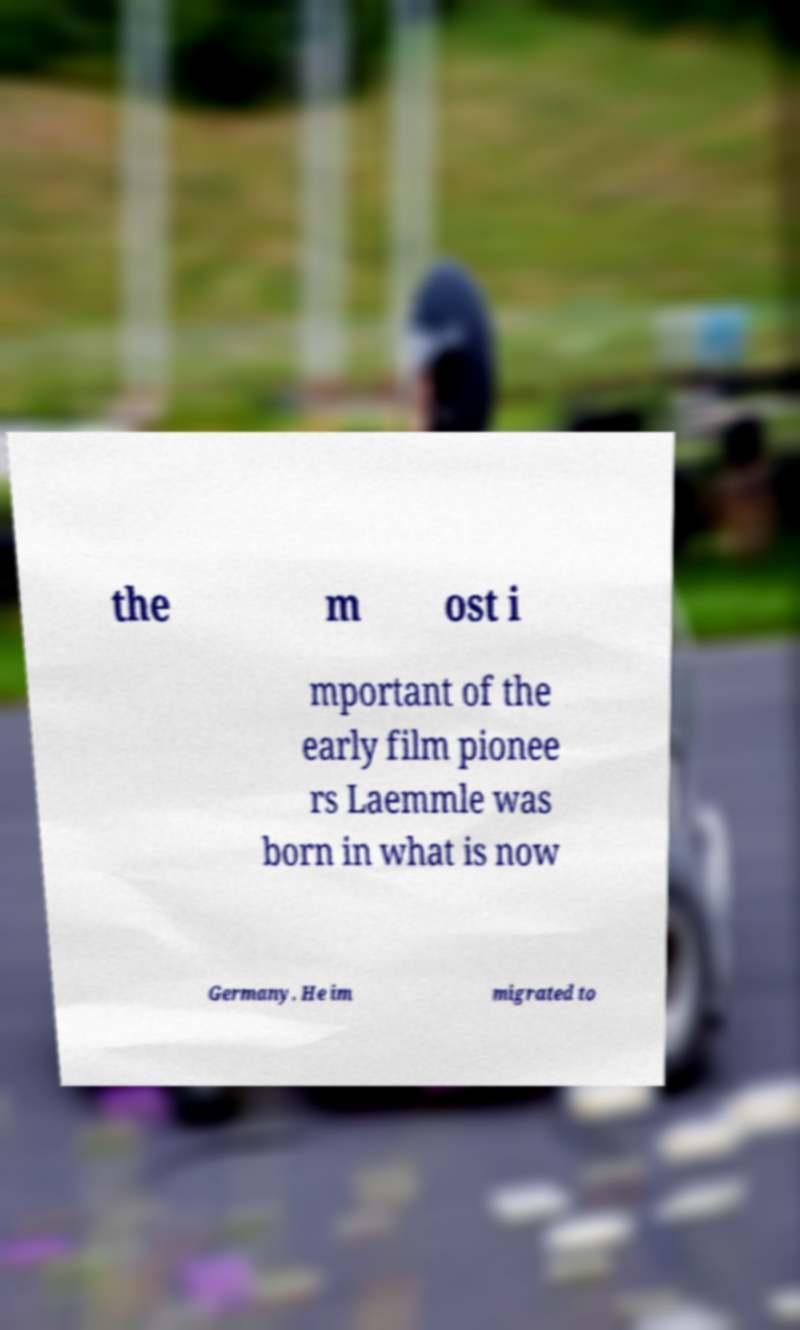Please read and relay the text visible in this image. What does it say? the m ost i mportant of the early film pionee rs Laemmle was born in what is now Germany. He im migrated to 